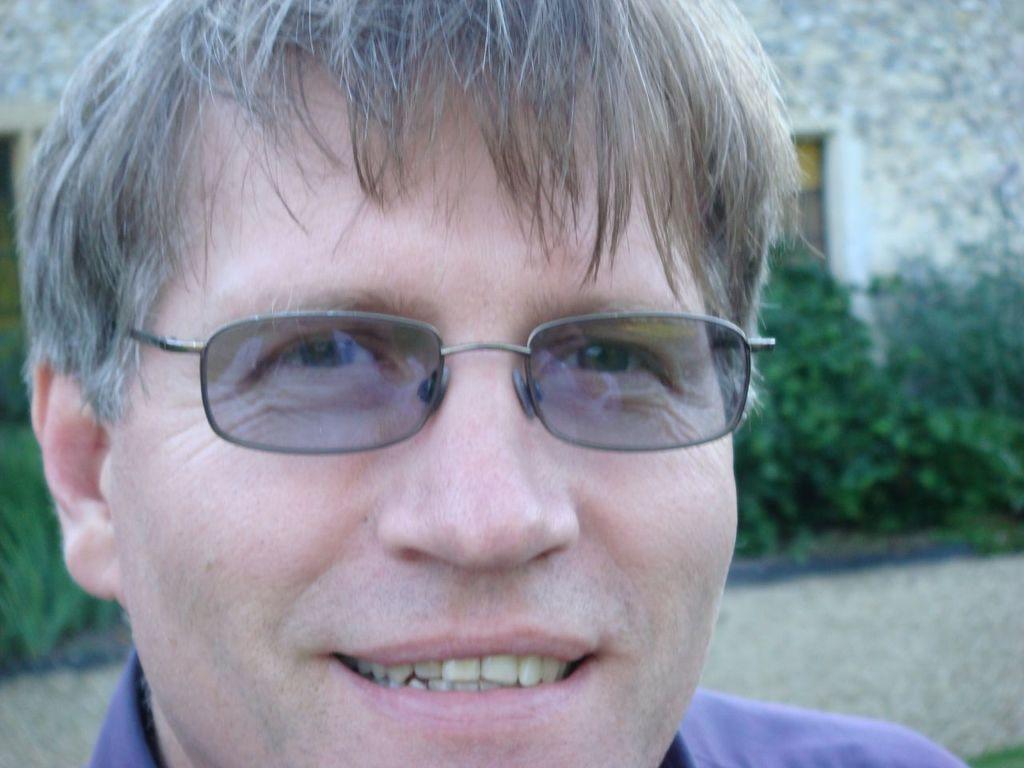Describe this image in one or two sentences. In this picture we can see a man is smiling, he is wearing spectacles, in the background there is a wall and some plants. 